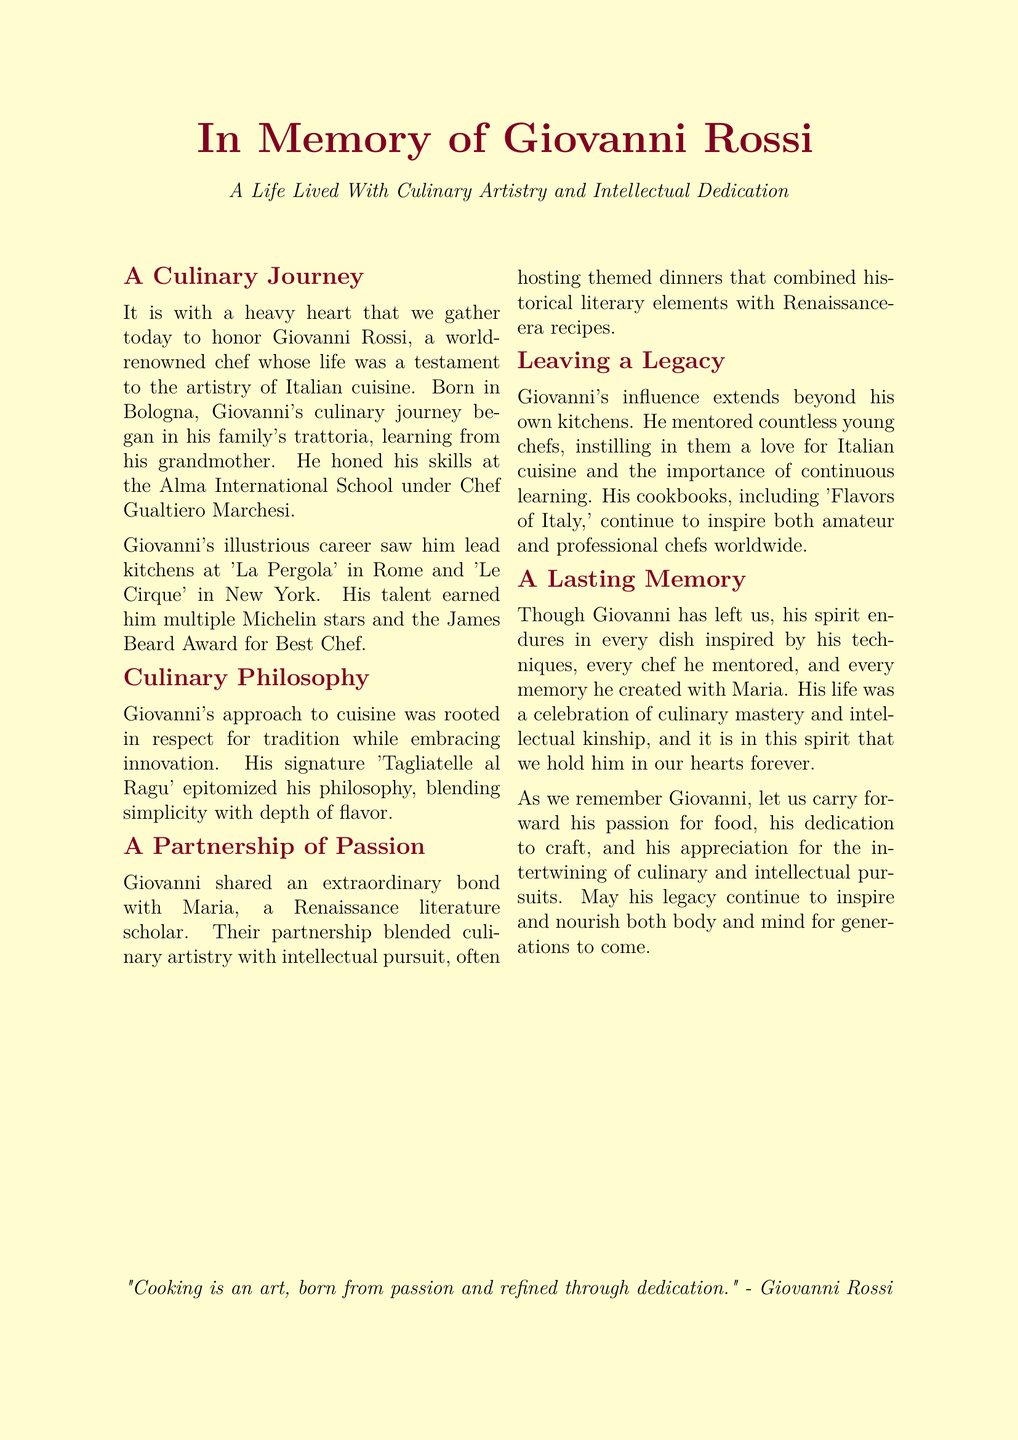What is Giovanni Rossi's birthplace? Giovanni was born in Bologna, which is mentioned as his birthplace in the document.
Answer: Bologna Which award did Giovanni Rossi receive? The document specifies that Giovanni earned the James Beard Award for Best Chef during his career.
Answer: James Beard Award What is the title of Giovanni's cookbook? The document mentions his cookbook titled 'Flavors of Italy', which reflects his culinary influence.
Answer: Flavors of Italy Who did Giovanni share a partnership with? The eulogy states that Giovanni had an extraordinary bond with Maria, providing insight into his personal life.
Answer: Maria What was Giovanni's signature dish? The text identifies 'Tagliatelle al Ragu' as Giovanni's signature dish, showcasing his culinary philosophy.
Answer: Tagliatelle al Ragu What did Giovanni's culinary philosophy emphasize? The document discusses how Giovanni's culinary philosophy emphasized respect for tradition while embracing innovation.
Answer: Respect for tradition In which cities did Giovanni lead kitchens? Giovanni led kitchens in Rome and New York, as noted in the eulogy.
Answer: Rome and New York How did Giovanni influence young chefs? The document indicates that he mentored countless young chefs, instilling them a love for Italian cuisine.
Answer: Mentoring What was the focus of the themed dinners hosted by Giovanni and Maria? The eulogy highlights that the themed dinners combined historical literary elements with Renaissance-era recipes.
Answer: Historical literary elements 